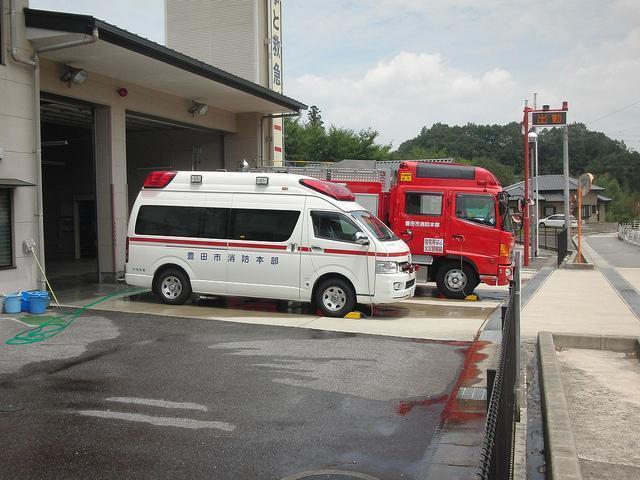How many vehicles are pictures?
Give a very brief answer. 3. How many people are wearing white shirts?
Give a very brief answer. 0. 